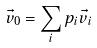<formula> <loc_0><loc_0><loc_500><loc_500>\vec { v } _ { 0 } = \sum _ { i } p _ { i } \vec { v } _ { i }</formula> 